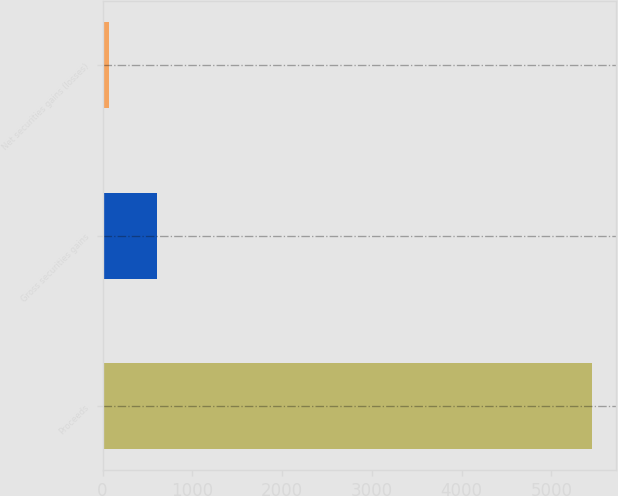<chart> <loc_0><loc_0><loc_500><loc_500><bar_chart><fcel>Proceeds<fcel>Gross securities gains<fcel>Net securities gains (losses)<nl><fcel>5451<fcel>607.2<fcel>69<nl></chart> 